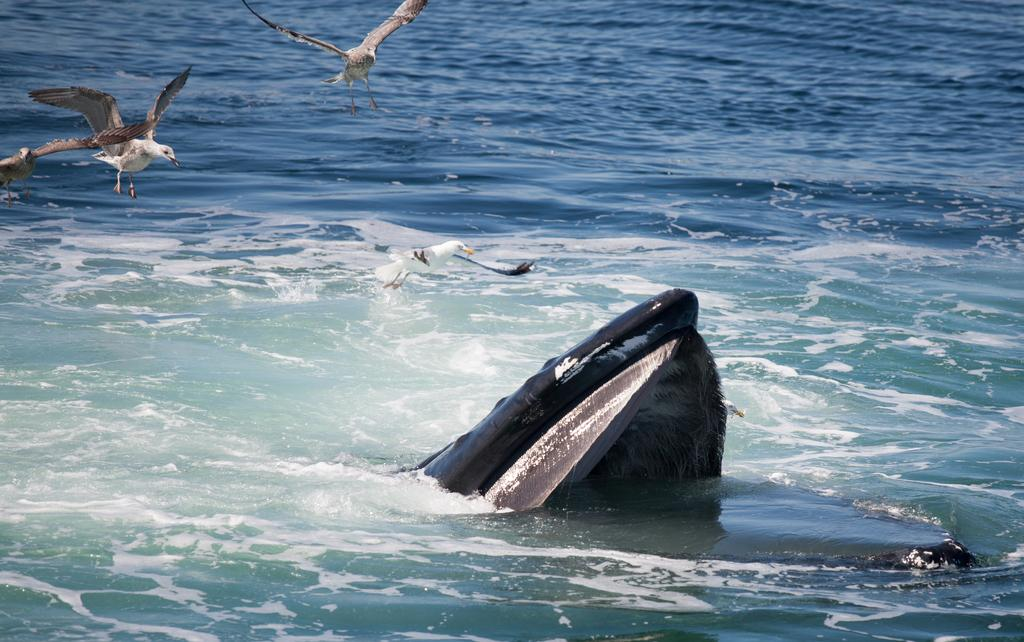What is at the bottom of the image? There is water at the bottom of the image. What can be seen in the middle of the image? There appears to be a fish in the middle of the image. What type of animals are on the left side of the image? There are birds on the left side of the image. What type of board is being used by the police in the image? There is no board or police present in the image. Is it raining in the image? The provided facts do not mention any rain, so we cannot determine if it is raining in the image. 